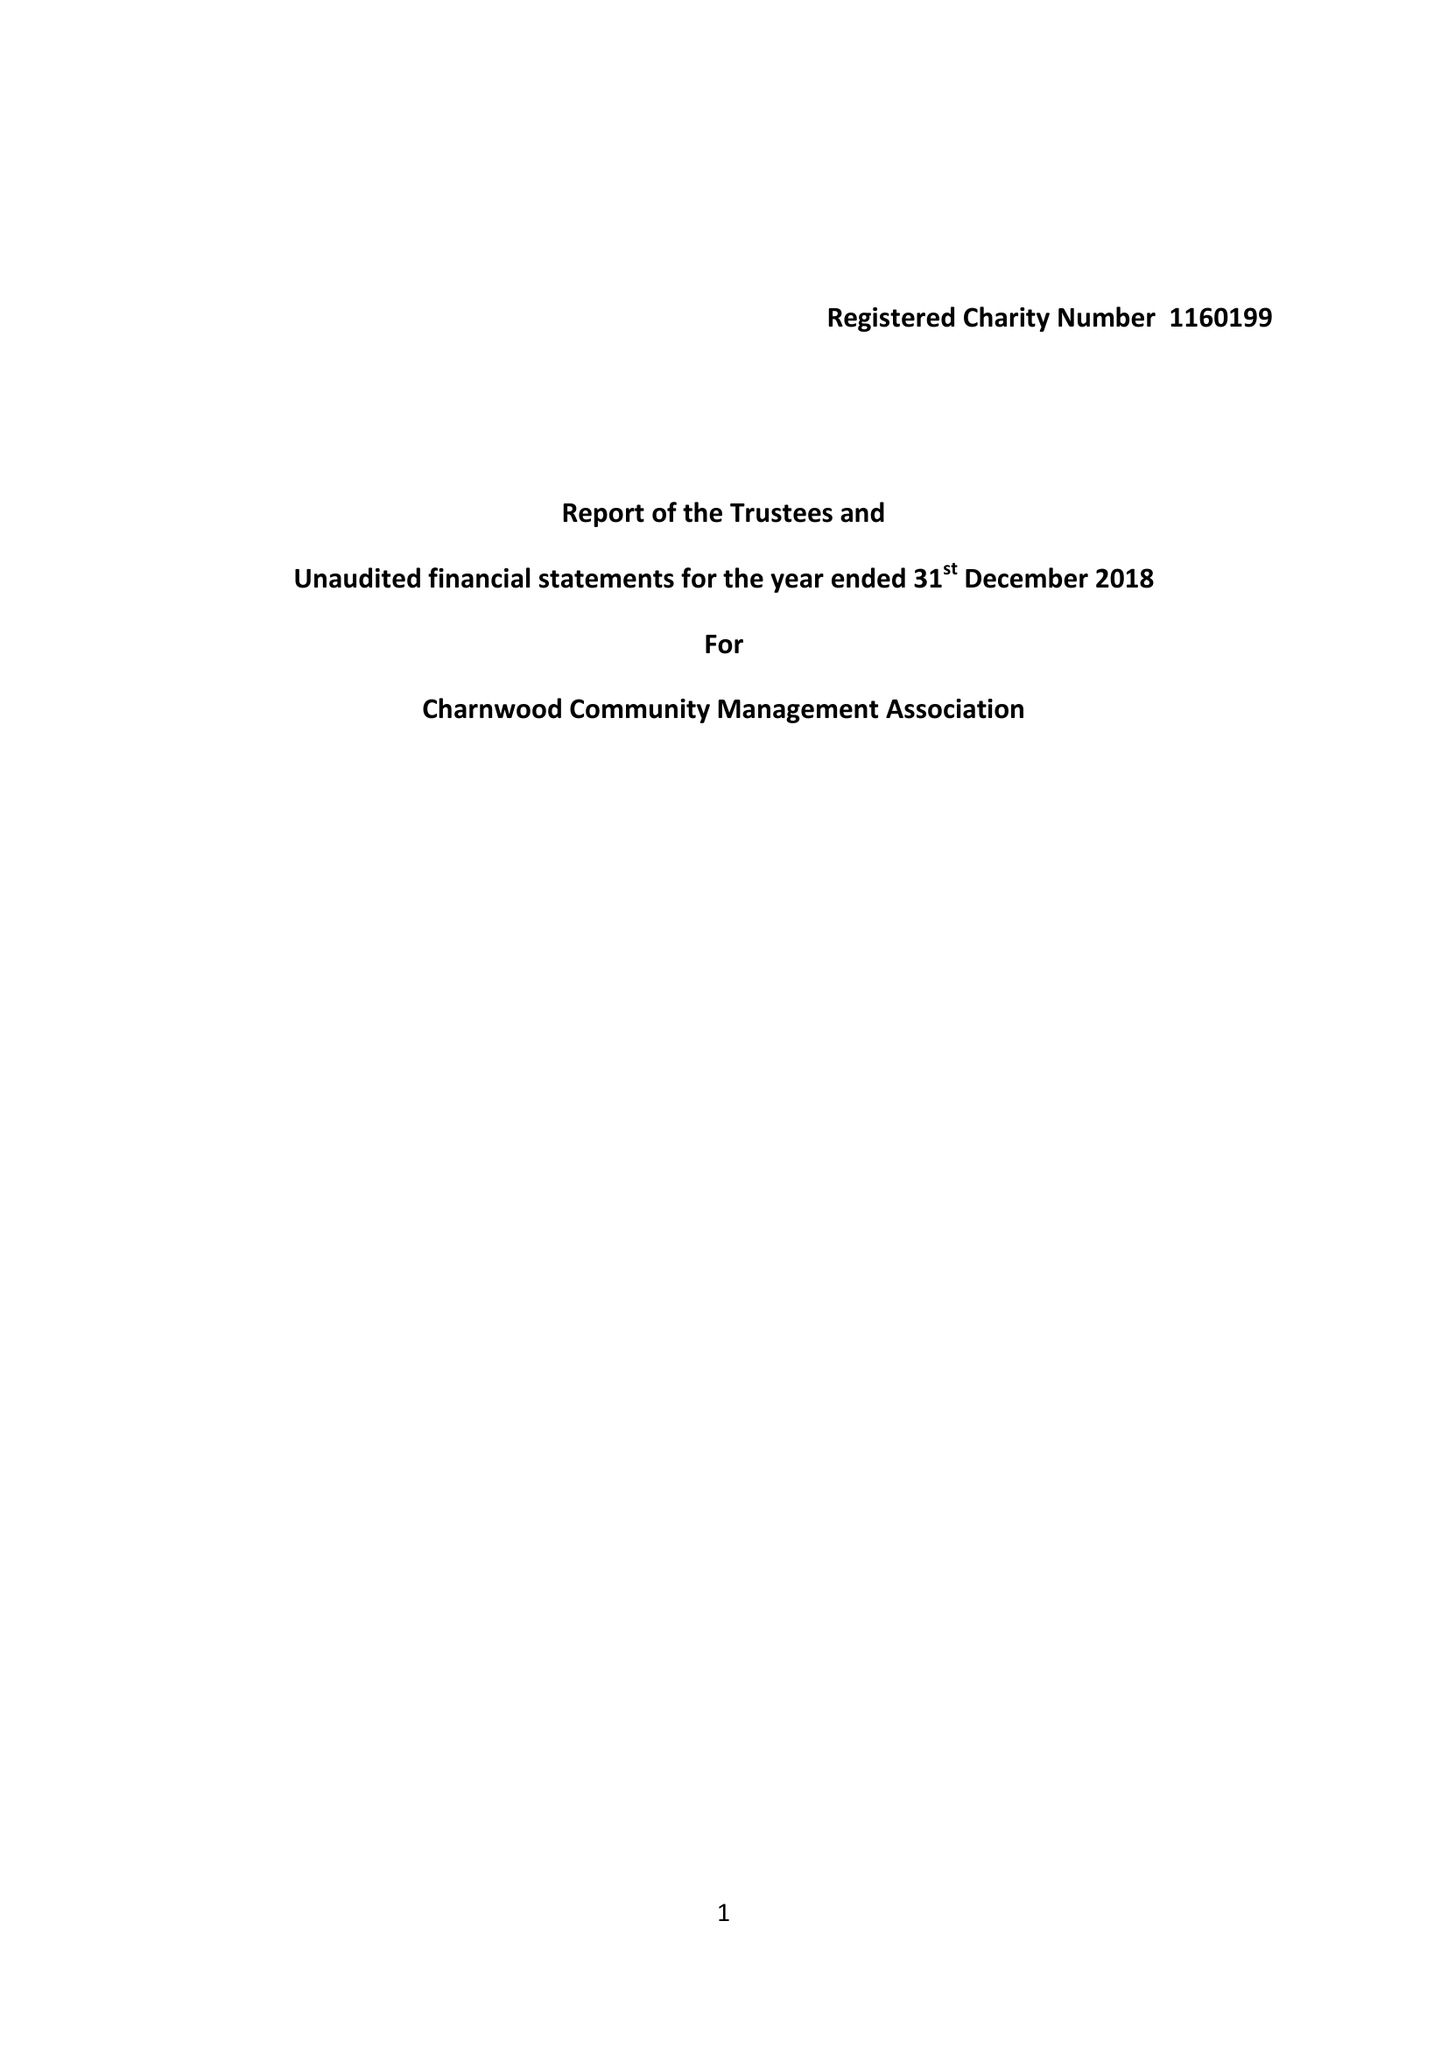What is the value for the address__street_line?
Answer the question using a single word or phrase. 23 WEST HILL 